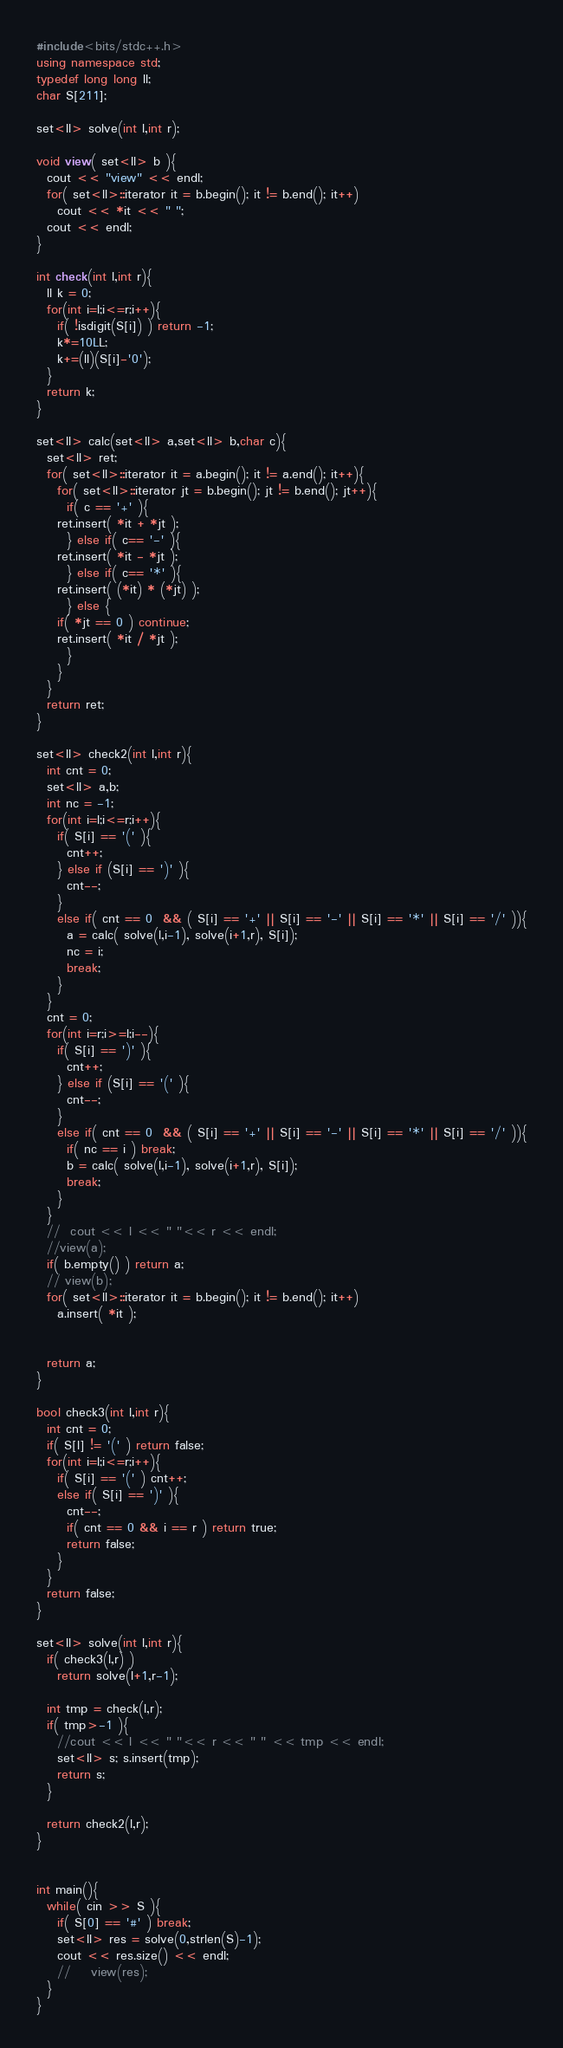<code> <loc_0><loc_0><loc_500><loc_500><_C++_>#include<bits/stdc++.h>
using namespace std;
typedef long long ll;
char S[211];
 
set<ll> solve(int l,int r);
 
void view( set<ll> b ){
  cout << "view" << endl;
  for( set<ll>::iterator it = b.begin(); it != b.end(); it++)
    cout << *it << " ";
  cout << endl;
}
 
int check(int l,int r){
  ll k = 0;
  for(int i=l;i<=r;i++){
    if( !isdigit(S[i]) ) return -1;
    k*=10LL;
    k+=(ll)(S[i]-'0');
  }
  return k;
}
 
set<ll> calc(set<ll> a,set<ll> b,char c){
  set<ll> ret;
  for( set<ll>::iterator it = a.begin(); it != a.end(); it++){
    for( set<ll>::iterator jt = b.begin(); jt != b.end(); jt++){
      if( c == '+' ){
    ret.insert( *it + *jt );
      } else if( c== '-' ){
    ret.insert( *it - *jt );
      } else if( c== '*' ){
    ret.insert( (*it) * (*jt) );
      } else {
    if( *jt == 0 ) continue;
    ret.insert( *it / *jt );
      }
    }
  }
  return ret;
}
 
set<ll> check2(int l,int r){
  int cnt = 0;
  set<ll> a,b;
  int nc = -1;
  for(int i=l;i<=r;i++){
    if( S[i] == '(' ){
      cnt++;
    } else if (S[i] == ')' ){
      cnt--;
    }
    else if( cnt == 0  && ( S[i] == '+' || S[i] == '-' || S[i] == '*' || S[i] == '/' )){
      a = calc( solve(l,i-1), solve(i+1,r), S[i]);
      nc = i;
      break;
    }
  }
  cnt = 0; 
  for(int i=r;i>=l;i--){
    if( S[i] == ')' ){
      cnt++;
    } else if (S[i] == '(' ){
      cnt--;
    }
    else if( cnt == 0  && ( S[i] == '+' || S[i] == '-' || S[i] == '*' || S[i] == '/' )){
      if( nc == i ) break;
      b = calc( solve(l,i-1), solve(i+1,r), S[i]);
      break;
    }
  }
  //  cout << l << " "<< r << endl;
  //view(a);
  if( b.empty() ) return a;
  // view(b);
  for( set<ll>::iterator it = b.begin(); it != b.end(); it++)
    a.insert( *it );
 
 
  return a;
}
 
bool check3(int l,int r){
  int cnt = 0;
  if( S[l] != '(' ) return false;
  for(int i=l;i<=r;i++){
    if( S[i] == '(' ) cnt++;
    else if( S[i] == ')' ){
      cnt--;
      if( cnt == 0 && i == r ) return true;      
      return false;
    }
  }
  return false;
}
 
set<ll> solve(int l,int r){
  if( check3(l,r) )
    return solve(l+1,r-1);
   
  int tmp = check(l,r);
  if( tmp>-1 ){
    //cout << l << " "<< r << " " << tmp << endl;
    set<ll> s; s.insert(tmp);
    return s;
  }
   
  return check2(l,r);
}
 
 
int main(){
  while( cin >> S ){
    if( S[0] == '#' ) break;
    set<ll> res = solve(0,strlen(S)-1);
    cout << res.size() << endl;
    //    view(res);
  }
}</code> 